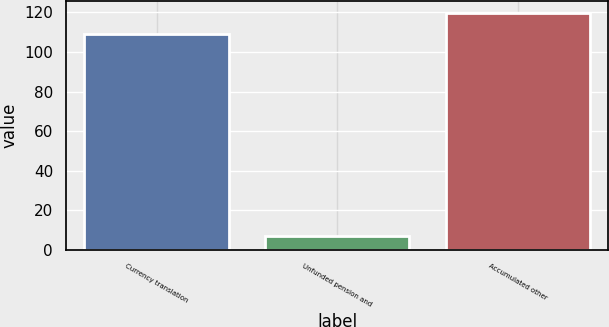<chart> <loc_0><loc_0><loc_500><loc_500><bar_chart><fcel>Currency translation<fcel>Unfunded pension and<fcel>Accumulated other<nl><fcel>109<fcel>7<fcel>119.9<nl></chart> 